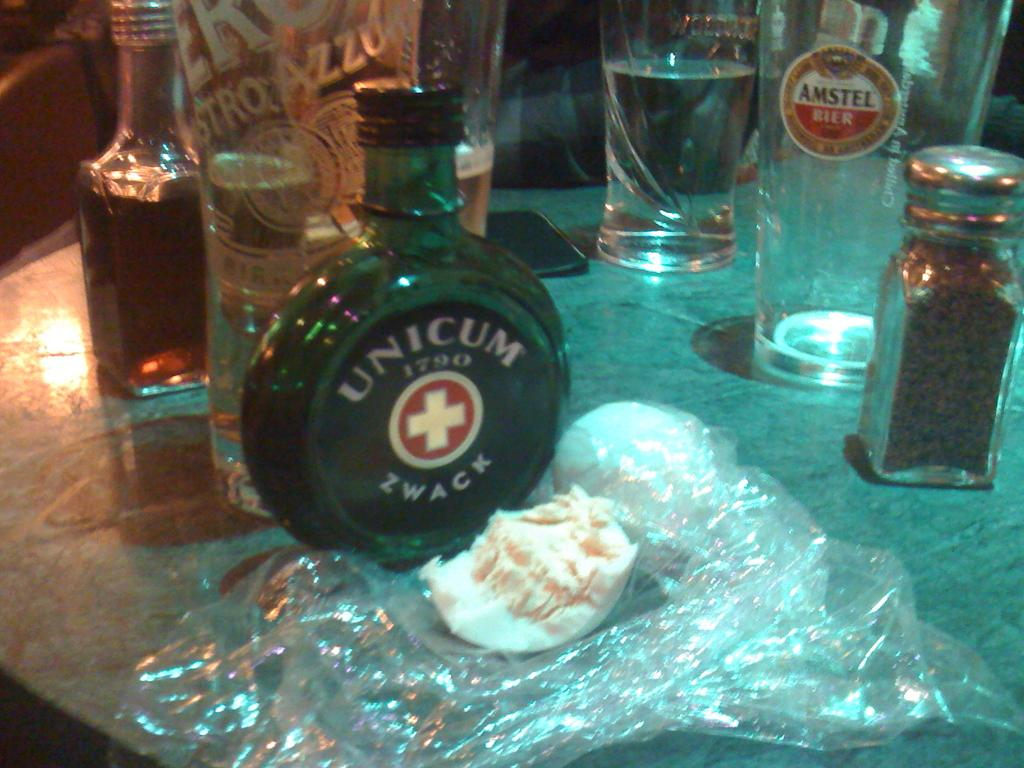Provide a one-sentence caption for the provided image. table with bottle of unicum zwack, anstel beer, and other things. 